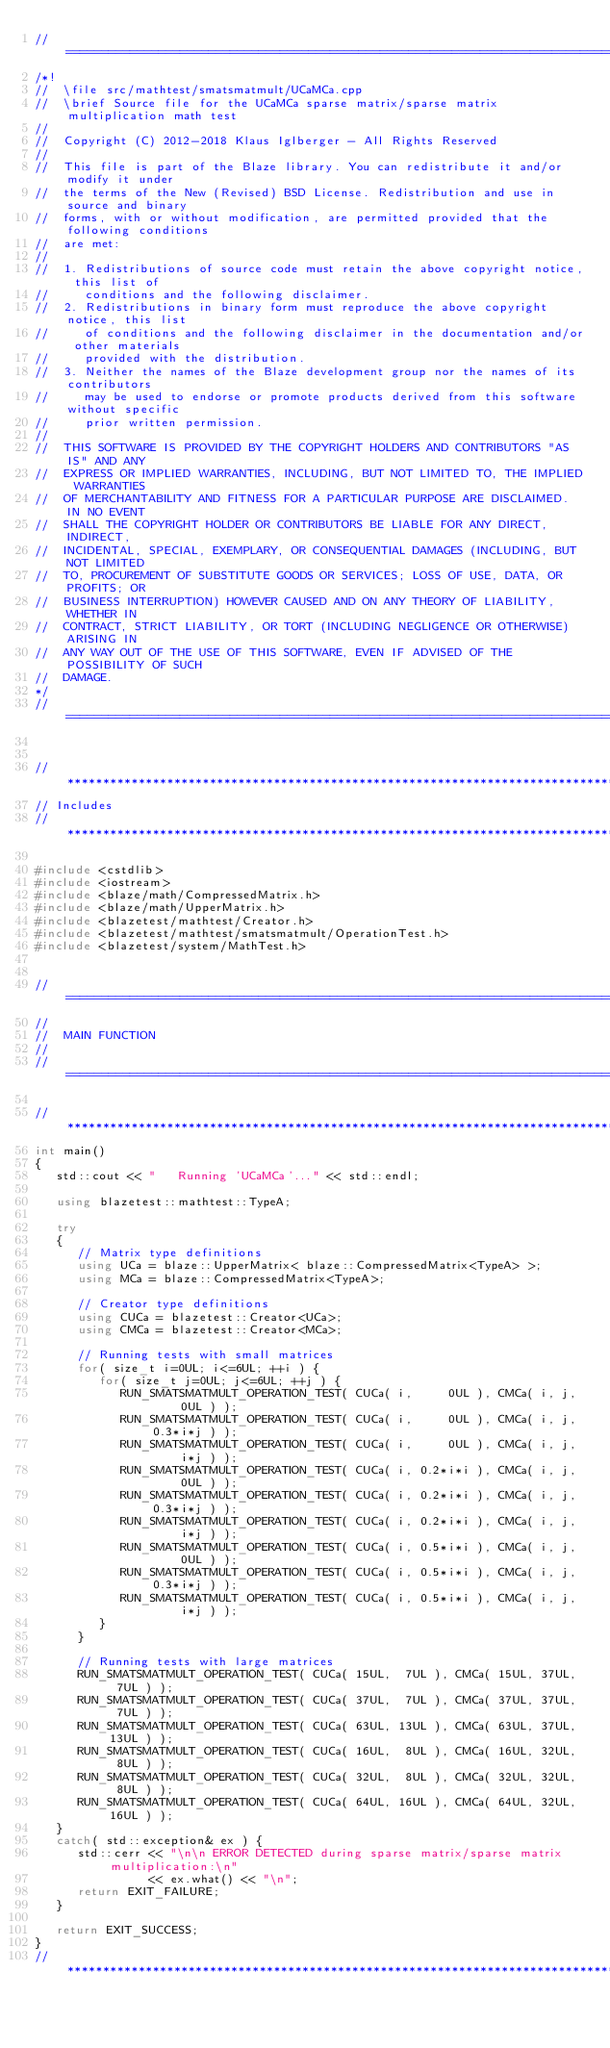<code> <loc_0><loc_0><loc_500><loc_500><_C++_>//=================================================================================================
/*!
//  \file src/mathtest/smatsmatmult/UCaMCa.cpp
//  \brief Source file for the UCaMCa sparse matrix/sparse matrix multiplication math test
//
//  Copyright (C) 2012-2018 Klaus Iglberger - All Rights Reserved
//
//  This file is part of the Blaze library. You can redistribute it and/or modify it under
//  the terms of the New (Revised) BSD License. Redistribution and use in source and binary
//  forms, with or without modification, are permitted provided that the following conditions
//  are met:
//
//  1. Redistributions of source code must retain the above copyright notice, this list of
//     conditions and the following disclaimer.
//  2. Redistributions in binary form must reproduce the above copyright notice, this list
//     of conditions and the following disclaimer in the documentation and/or other materials
//     provided with the distribution.
//  3. Neither the names of the Blaze development group nor the names of its contributors
//     may be used to endorse or promote products derived from this software without specific
//     prior written permission.
//
//  THIS SOFTWARE IS PROVIDED BY THE COPYRIGHT HOLDERS AND CONTRIBUTORS "AS IS" AND ANY
//  EXPRESS OR IMPLIED WARRANTIES, INCLUDING, BUT NOT LIMITED TO, THE IMPLIED WARRANTIES
//  OF MERCHANTABILITY AND FITNESS FOR A PARTICULAR PURPOSE ARE DISCLAIMED. IN NO EVENT
//  SHALL THE COPYRIGHT HOLDER OR CONTRIBUTORS BE LIABLE FOR ANY DIRECT, INDIRECT,
//  INCIDENTAL, SPECIAL, EXEMPLARY, OR CONSEQUENTIAL DAMAGES (INCLUDING, BUT NOT LIMITED
//  TO, PROCUREMENT OF SUBSTITUTE GOODS OR SERVICES; LOSS OF USE, DATA, OR PROFITS; OR
//  BUSINESS INTERRUPTION) HOWEVER CAUSED AND ON ANY THEORY OF LIABILITY, WHETHER IN
//  CONTRACT, STRICT LIABILITY, OR TORT (INCLUDING NEGLIGENCE OR OTHERWISE) ARISING IN
//  ANY WAY OUT OF THE USE OF THIS SOFTWARE, EVEN IF ADVISED OF THE POSSIBILITY OF SUCH
//  DAMAGE.
*/
//=================================================================================================


//*************************************************************************************************
// Includes
//*************************************************************************************************

#include <cstdlib>
#include <iostream>
#include <blaze/math/CompressedMatrix.h>
#include <blaze/math/UpperMatrix.h>
#include <blazetest/mathtest/Creator.h>
#include <blazetest/mathtest/smatsmatmult/OperationTest.h>
#include <blazetest/system/MathTest.h>


//=================================================================================================
//
//  MAIN FUNCTION
//
//=================================================================================================

//*************************************************************************************************
int main()
{
   std::cout << "   Running 'UCaMCa'..." << std::endl;

   using blazetest::mathtest::TypeA;

   try
   {
      // Matrix type definitions
      using UCa = blaze::UpperMatrix< blaze::CompressedMatrix<TypeA> >;
      using MCa = blaze::CompressedMatrix<TypeA>;

      // Creator type definitions
      using CUCa = blazetest::Creator<UCa>;
      using CMCa = blazetest::Creator<MCa>;

      // Running tests with small matrices
      for( size_t i=0UL; i<=6UL; ++i ) {
         for( size_t j=0UL; j<=6UL; ++j ) {
            RUN_SMATSMATMULT_OPERATION_TEST( CUCa( i,     0UL ), CMCa( i, j,     0UL ) );
            RUN_SMATSMATMULT_OPERATION_TEST( CUCa( i,     0UL ), CMCa( i, j, 0.3*i*j ) );
            RUN_SMATSMATMULT_OPERATION_TEST( CUCa( i,     0UL ), CMCa( i, j,     i*j ) );
            RUN_SMATSMATMULT_OPERATION_TEST( CUCa( i, 0.2*i*i ), CMCa( i, j,     0UL ) );
            RUN_SMATSMATMULT_OPERATION_TEST( CUCa( i, 0.2*i*i ), CMCa( i, j, 0.3*i*j ) );
            RUN_SMATSMATMULT_OPERATION_TEST( CUCa( i, 0.2*i*i ), CMCa( i, j,     i*j ) );
            RUN_SMATSMATMULT_OPERATION_TEST( CUCa( i, 0.5*i*i ), CMCa( i, j,     0UL ) );
            RUN_SMATSMATMULT_OPERATION_TEST( CUCa( i, 0.5*i*i ), CMCa( i, j, 0.3*i*j ) );
            RUN_SMATSMATMULT_OPERATION_TEST( CUCa( i, 0.5*i*i ), CMCa( i, j,     i*j ) );
         }
      }

      // Running tests with large matrices
      RUN_SMATSMATMULT_OPERATION_TEST( CUCa( 15UL,  7UL ), CMCa( 15UL, 37UL,  7UL ) );
      RUN_SMATSMATMULT_OPERATION_TEST( CUCa( 37UL,  7UL ), CMCa( 37UL, 37UL,  7UL ) );
      RUN_SMATSMATMULT_OPERATION_TEST( CUCa( 63UL, 13UL ), CMCa( 63UL, 37UL, 13UL ) );
      RUN_SMATSMATMULT_OPERATION_TEST( CUCa( 16UL,  8UL ), CMCa( 16UL, 32UL,  8UL ) );
      RUN_SMATSMATMULT_OPERATION_TEST( CUCa( 32UL,  8UL ), CMCa( 32UL, 32UL,  8UL ) );
      RUN_SMATSMATMULT_OPERATION_TEST( CUCa( 64UL, 16UL ), CMCa( 64UL, 32UL, 16UL ) );
   }
   catch( std::exception& ex ) {
      std::cerr << "\n\n ERROR DETECTED during sparse matrix/sparse matrix multiplication:\n"
                << ex.what() << "\n";
      return EXIT_FAILURE;
   }

   return EXIT_SUCCESS;
}
//*************************************************************************************************
</code> 